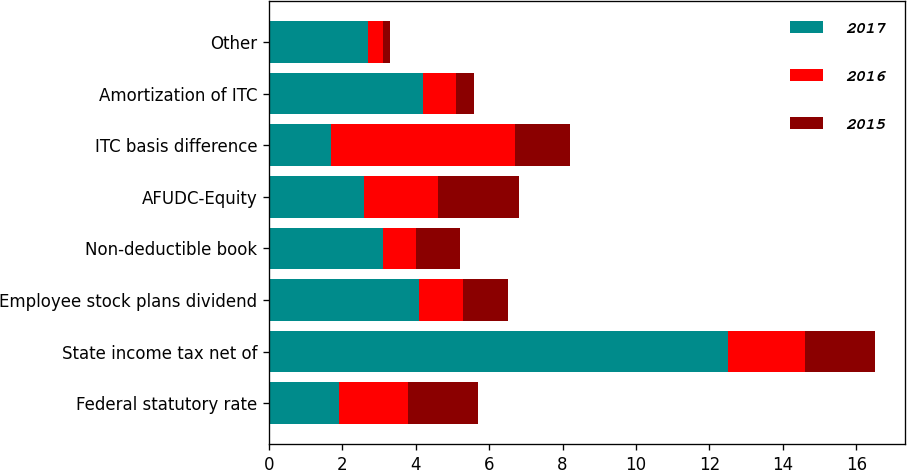<chart> <loc_0><loc_0><loc_500><loc_500><stacked_bar_chart><ecel><fcel>Federal statutory rate<fcel>State income tax net of<fcel>Employee stock plans dividend<fcel>Non-deductible book<fcel>AFUDC-Equity<fcel>ITC basis difference<fcel>Amortization of ITC<fcel>Other<nl><fcel>2017<fcel>1.9<fcel>12.5<fcel>4.1<fcel>3.1<fcel>2.6<fcel>1.7<fcel>4.2<fcel>2.7<nl><fcel>2016<fcel>1.9<fcel>2.1<fcel>1.2<fcel>0.9<fcel>2<fcel>5<fcel>0.9<fcel>0.4<nl><fcel>2015<fcel>1.9<fcel>1.9<fcel>1.2<fcel>1.2<fcel>2.2<fcel>1.5<fcel>0.5<fcel>0.2<nl></chart> 